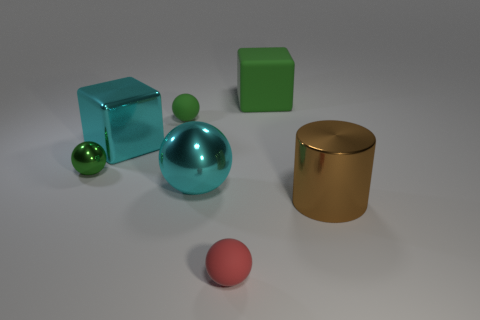Subtract all cyan balls. How many balls are left? 3 Subtract all brown cylinders. How many green spheres are left? 2 Add 1 red objects. How many objects exist? 8 Subtract all red spheres. How many spheres are left? 3 Subtract all cylinders. How many objects are left? 6 Subtract all cyan spheres. Subtract all blue blocks. How many spheres are left? 3 Subtract all small red things. Subtract all cubes. How many objects are left? 4 Add 6 large balls. How many large balls are left? 7 Add 6 big cyan metal spheres. How many big cyan metal spheres exist? 7 Subtract 1 green cubes. How many objects are left? 6 